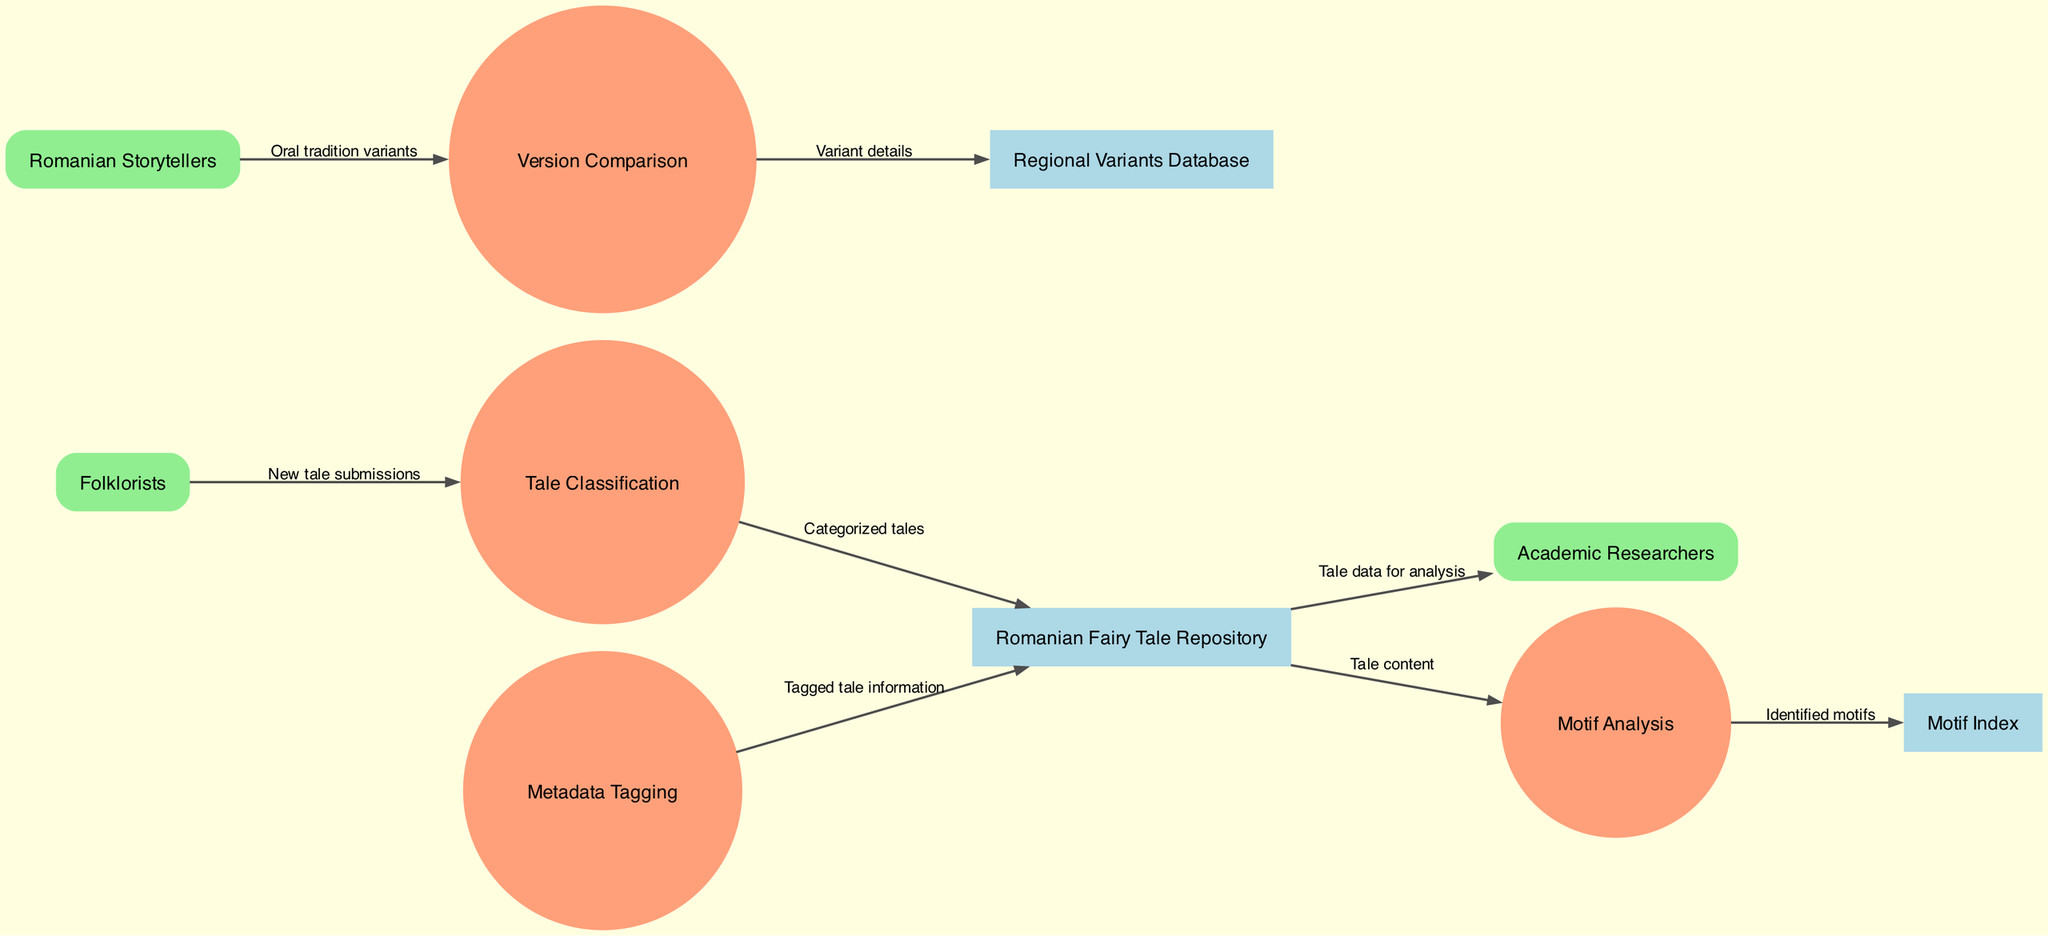What are the external entities in this diagram? The diagram lists three external entities: Folklorists, Romanian Storytellers, and Academic Researchers. These are the sources of data and information entering the system.
Answer: Folklorists, Romanian Storytellers, Academic Researchers How many processes are represented in the diagram? There are four processes in the diagram: Tale Classification, Motif Analysis, Version Comparison, and Metadata Tagging. Counting these processes gives the total number.
Answer: 4 What data flows from Folklorists to Tale Classification? Folklorists submit new tales, which are categorized by the Tale Classification process. The label on the data flow specifies this relationship.
Answer: New tale submissions Which data store receives categorized tales? The data flow from the Tale Classification process to the Romanian Fairy Tale Repository indicates that categorized tales are stored there. This is shown in the diagram's flow.
Answer: Romanian Fairy Tale Repository What data flow comes from the Version Comparison process? The Version Comparison process sends variant details to the Regional Variants Database, as indicated in the data flow labels. This describes the outflow from this process.
Answer: Variant details What is the relationship between Motif Analysis and the Motif Index? The Motif Analysis process outputs identified motifs to the Motif Index, as per the data flow shown in the diagram. This indicates a direct link between the two components.
Answer: Identified motifs How many data stores are mentioned in the diagram? There are three data stores listed: Romanian Fairy Tale Repository, Motif Index, and Regional Variants Database. Counting these entries provides the total.
Answer: 3 Who receives tale data for analysis? Academic Researchers receive tale data from the Romanian Fairy Tale Repository, as evident from the data flow connecting these entities in the diagram.
Answer: Academic Researchers What is the purpose of Metadata Tagging in the context of this diagram? The Metadata Tagging process adds tagged tale information to the Romanian Fairy Tale Repository, indicating its role in enriching the dataset with relevant metadata.
Answer: Tagged tale information 